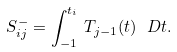<formula> <loc_0><loc_0><loc_500><loc_500>S ^ { - } _ { i j } = \int _ { - 1 } ^ { t _ { i } } \, T _ { j - 1 } ( t ) \, \ D t .</formula> 